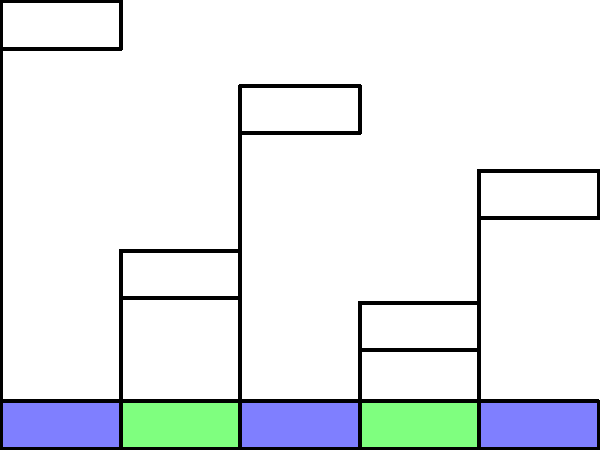Based on the bar graph showing protein content in common staple foods, which food item would provide the most protein per 100g serving, and how much more protein does it contain compared to the food item with the lowest protein content? To answer this question, we need to follow these steps:

1. Identify the food item with the highest protein content:
   By examining the bar graph, we can see that Beans have the tallest bar, indicating the highest protein content at 8.5g per 100g.

2. Identify the food item with the lowest protein content:
   The shortest bar corresponds to Pasta, which has 2.1g of protein per 100g.

3. Calculate the difference in protein content:
   To find how much more protein Beans contain compared to Pasta, we subtract:
   $$8.5g - 2.1g = 6.4g$$

This question is particularly relevant for a senior citizen facing food insecurity because it highlights the importance of choosing nutrient-dense foods. Beans, being high in protein and typically affordable, could be a good choice for maintaining muscle mass and overall health on a limited budget.
Answer: Beans; 6.4g more than Pasta 